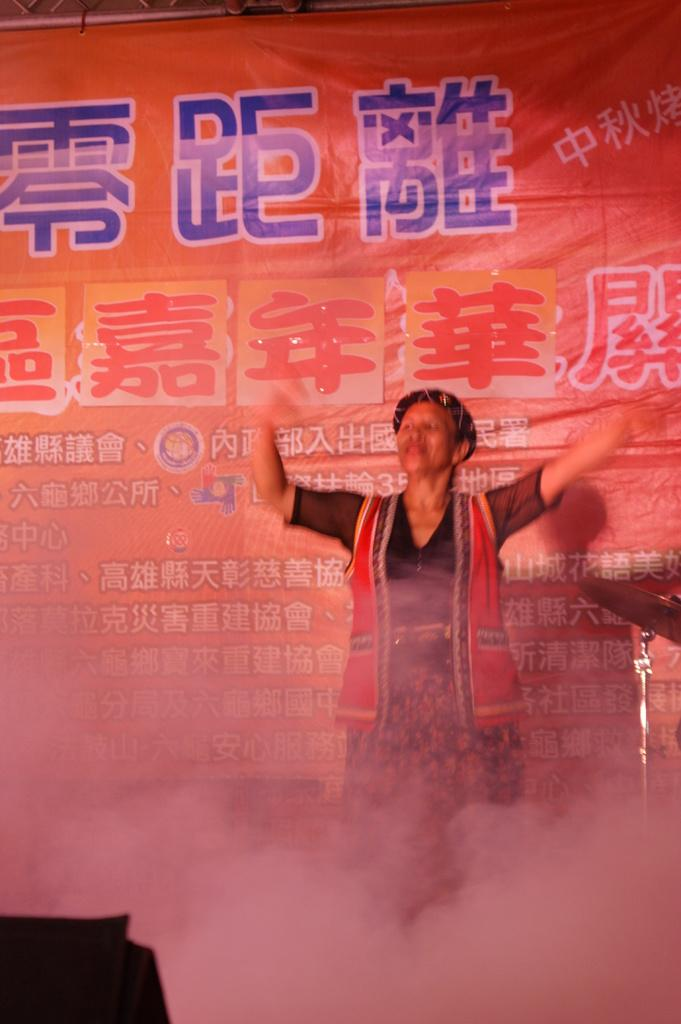What is the person in the image doing? There is a person dancing in the image. What else can be seen in the image besides the person dancing? There is smoke visible in the image. What is present in the background of the image? There is a banner with writing in the background of the image. What type of produce is being displayed on the person's head in the image? There is no produce present in the image; the person is dancing with no visible produce on their head. 